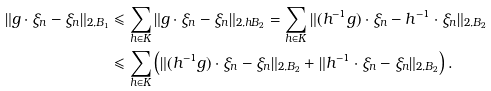Convert formula to latex. <formula><loc_0><loc_0><loc_500><loc_500>\| g \cdot \xi _ { n } - \xi _ { n } \| _ { 2 , B _ { 1 } } & \leqslant \sum _ { h \in K } \| g \cdot \xi _ { n } - \xi _ { n } \| _ { 2 , h B _ { 2 } } = \sum _ { h \in K } \| ( h ^ { - 1 } g ) \cdot \xi _ { n } - h ^ { - 1 } \cdot \xi _ { n } \| _ { 2 , B _ { 2 } } \\ & \leqslant \sum _ { h \in K } \left ( \| ( h ^ { - 1 } g ) \cdot \xi _ { n } - \xi _ { n } \| _ { 2 , B _ { 2 } } + \| h ^ { - 1 } \cdot \xi _ { n } - \xi _ { n } \| _ { 2 , B _ { 2 } } \right ) .</formula> 